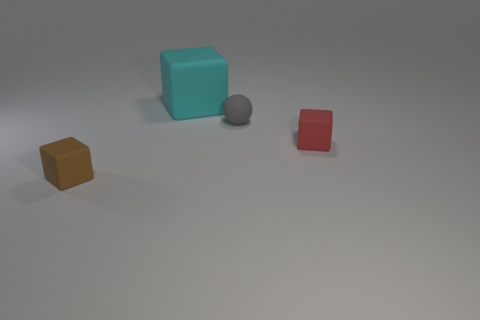There is a large rubber object that is the same shape as the small red object; what color is it?
Ensure brevity in your answer.  Cyan. Does the large object have the same color as the tiny sphere?
Make the answer very short. No. What number of cyan matte cubes are behind the small matte object in front of the small red block?
Make the answer very short. 1. What number of gray spheres have the same material as the small brown thing?
Provide a succinct answer. 1. Are there any large cyan blocks on the right side of the red rubber cube?
Give a very brief answer. No. The ball that is the same size as the red rubber thing is what color?
Keep it short and to the point. Gray. How many objects are either matte objects behind the red thing or small blue cylinders?
Offer a very short reply. 2. There is a block that is both right of the small brown matte cube and in front of the small matte sphere; what is its size?
Your response must be concise. Small. What number of other objects are there of the same size as the brown thing?
Offer a very short reply. 2. There is a tiny block that is behind the tiny block to the left of the small gray rubber ball that is behind the small red object; what is its color?
Your answer should be very brief. Red. 